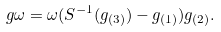<formula> <loc_0><loc_0><loc_500><loc_500>g \omega = \omega ( S ^ { - 1 } ( g _ { ( 3 ) } ) - g _ { ( 1 ) } ) g _ { ( 2 ) } .</formula> 